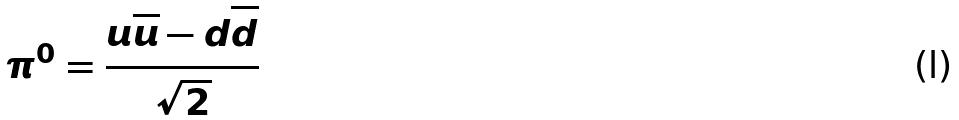<formula> <loc_0><loc_0><loc_500><loc_500>\pi ^ { 0 } = \frac { u \overline { u } - d \overline { d } } { \sqrt { 2 } }</formula> 